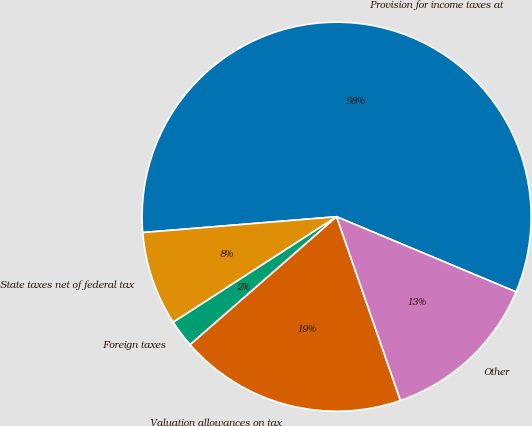Convert chart. <chart><loc_0><loc_0><loc_500><loc_500><pie_chart><fcel>Provision for income taxes at<fcel>State taxes net of federal tax<fcel>Foreign taxes<fcel>Valuation allowances on tax<fcel>Other<nl><fcel>57.6%<fcel>7.83%<fcel>2.3%<fcel>18.89%<fcel>13.36%<nl></chart> 